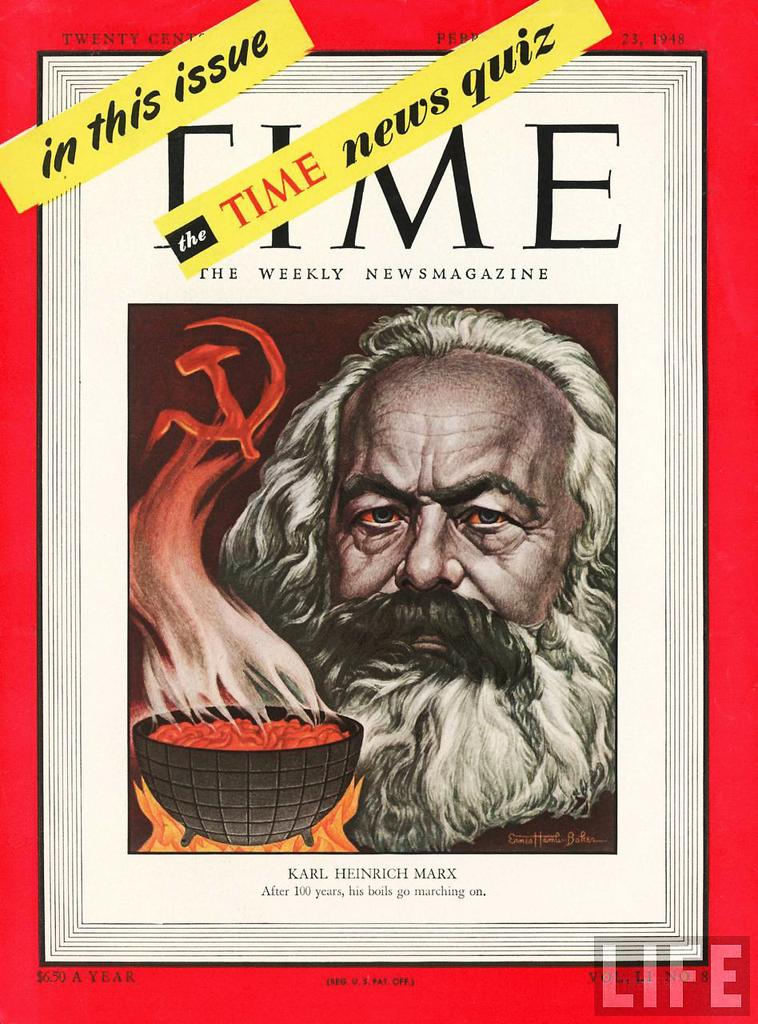<image>
Present a compact description of the photo's key features. The cover of Time magazine with an illustration of Karl Marx from 1948. 